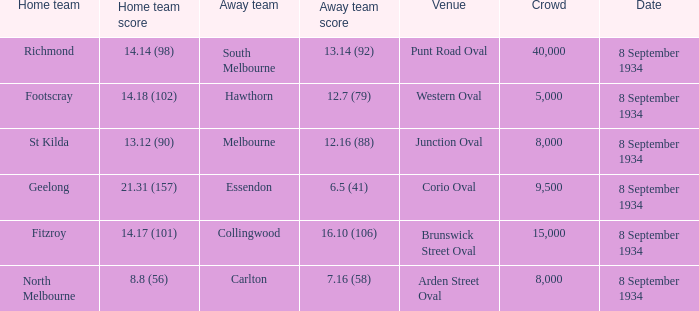When melbourne played as the away team, what was their score? 12.16 (88). 